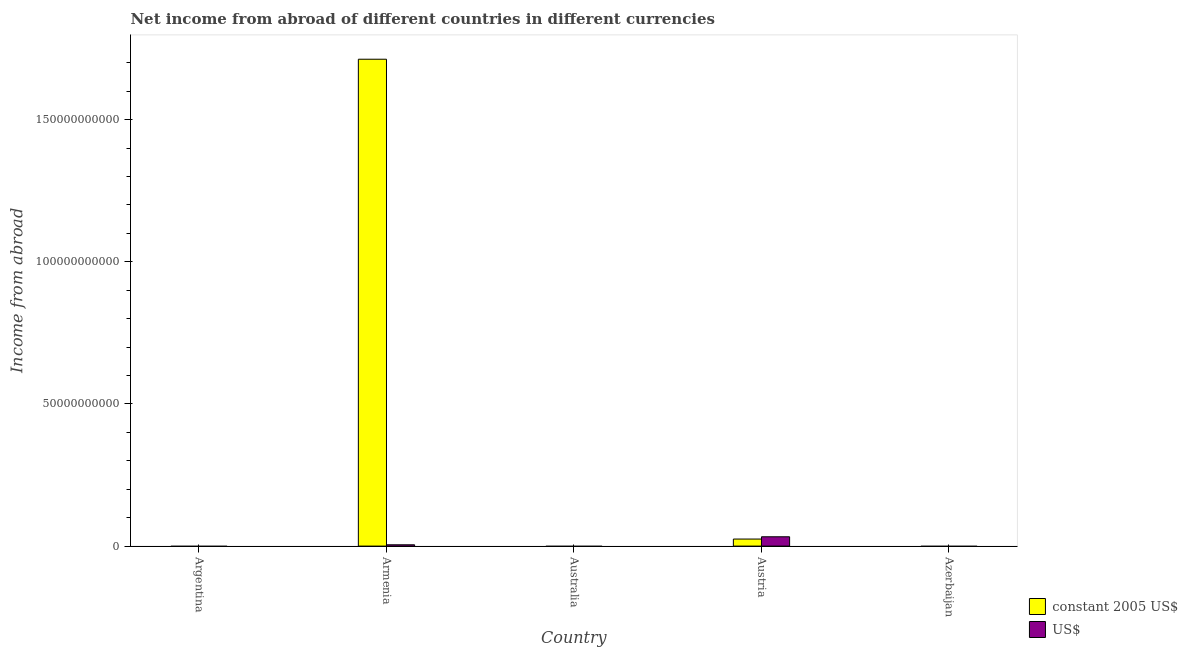How many bars are there on the 4th tick from the right?
Your answer should be very brief. 2. What is the label of the 2nd group of bars from the left?
Ensure brevity in your answer.  Armenia. Across all countries, what is the maximum income from abroad in constant 2005 us$?
Provide a short and direct response. 1.71e+11. Across all countries, what is the minimum income from abroad in us$?
Make the answer very short. 0. What is the total income from abroad in us$ in the graph?
Provide a short and direct response. 3.74e+09. What is the difference between the income from abroad in constant 2005 us$ in Australia and the income from abroad in us$ in Armenia?
Ensure brevity in your answer.  -4.58e+08. What is the average income from abroad in us$ per country?
Your response must be concise. 7.47e+08. What is the difference between the income from abroad in constant 2005 us$ and income from abroad in us$ in Armenia?
Make the answer very short. 1.71e+11. In how many countries, is the income from abroad in us$ greater than 40000000000 units?
Provide a succinct answer. 0. What is the ratio of the income from abroad in constant 2005 us$ in Armenia to that in Austria?
Your answer should be very brief. 69.18. What is the difference between the highest and the lowest income from abroad in constant 2005 us$?
Provide a succinct answer. 1.71e+11. Is the sum of the income from abroad in us$ in Armenia and Austria greater than the maximum income from abroad in constant 2005 us$ across all countries?
Keep it short and to the point. No. Are all the bars in the graph horizontal?
Your response must be concise. No. Does the graph contain grids?
Give a very brief answer. No. How are the legend labels stacked?
Your answer should be very brief. Vertical. What is the title of the graph?
Offer a very short reply. Net income from abroad of different countries in different currencies. Does "Goods and services" appear as one of the legend labels in the graph?
Ensure brevity in your answer.  No. What is the label or title of the X-axis?
Ensure brevity in your answer.  Country. What is the label or title of the Y-axis?
Keep it short and to the point. Income from abroad. What is the Income from abroad of constant 2005 US$ in Argentina?
Ensure brevity in your answer.  0. What is the Income from abroad of constant 2005 US$ in Armenia?
Offer a very short reply. 1.71e+11. What is the Income from abroad in US$ in Armenia?
Your answer should be compact. 4.58e+08. What is the Income from abroad in constant 2005 US$ in Australia?
Offer a very short reply. 0. What is the Income from abroad of constant 2005 US$ in Austria?
Give a very brief answer. 2.48e+09. What is the Income from abroad in US$ in Austria?
Provide a short and direct response. 3.28e+09. Across all countries, what is the maximum Income from abroad in constant 2005 US$?
Make the answer very short. 1.71e+11. Across all countries, what is the maximum Income from abroad of US$?
Provide a short and direct response. 3.28e+09. What is the total Income from abroad in constant 2005 US$ in the graph?
Offer a terse response. 1.74e+11. What is the total Income from abroad of US$ in the graph?
Make the answer very short. 3.74e+09. What is the difference between the Income from abroad in constant 2005 US$ in Armenia and that in Austria?
Offer a very short reply. 1.69e+11. What is the difference between the Income from abroad in US$ in Armenia and that in Austria?
Make the answer very short. -2.82e+09. What is the difference between the Income from abroad of constant 2005 US$ in Armenia and the Income from abroad of US$ in Austria?
Offer a terse response. 1.68e+11. What is the average Income from abroad of constant 2005 US$ per country?
Offer a very short reply. 3.47e+1. What is the average Income from abroad in US$ per country?
Give a very brief answer. 7.47e+08. What is the difference between the Income from abroad of constant 2005 US$ and Income from abroad of US$ in Armenia?
Keep it short and to the point. 1.71e+11. What is the difference between the Income from abroad of constant 2005 US$ and Income from abroad of US$ in Austria?
Ensure brevity in your answer.  -8.03e+08. What is the ratio of the Income from abroad of constant 2005 US$ in Armenia to that in Austria?
Ensure brevity in your answer.  69.18. What is the ratio of the Income from abroad of US$ in Armenia to that in Austria?
Ensure brevity in your answer.  0.14. What is the difference between the highest and the lowest Income from abroad in constant 2005 US$?
Keep it short and to the point. 1.71e+11. What is the difference between the highest and the lowest Income from abroad in US$?
Your response must be concise. 3.28e+09. 